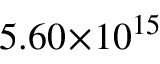Convert formula to latex. <formula><loc_0><loc_0><loc_500><loc_500>5 . 6 0 \, \times \, 1 0 ^ { 1 5 }</formula> 